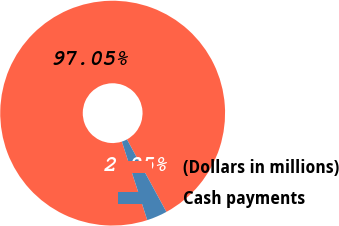<chart> <loc_0><loc_0><loc_500><loc_500><pie_chart><fcel>(Dollars in millions)<fcel>Cash payments<nl><fcel>97.05%<fcel>2.95%<nl></chart> 